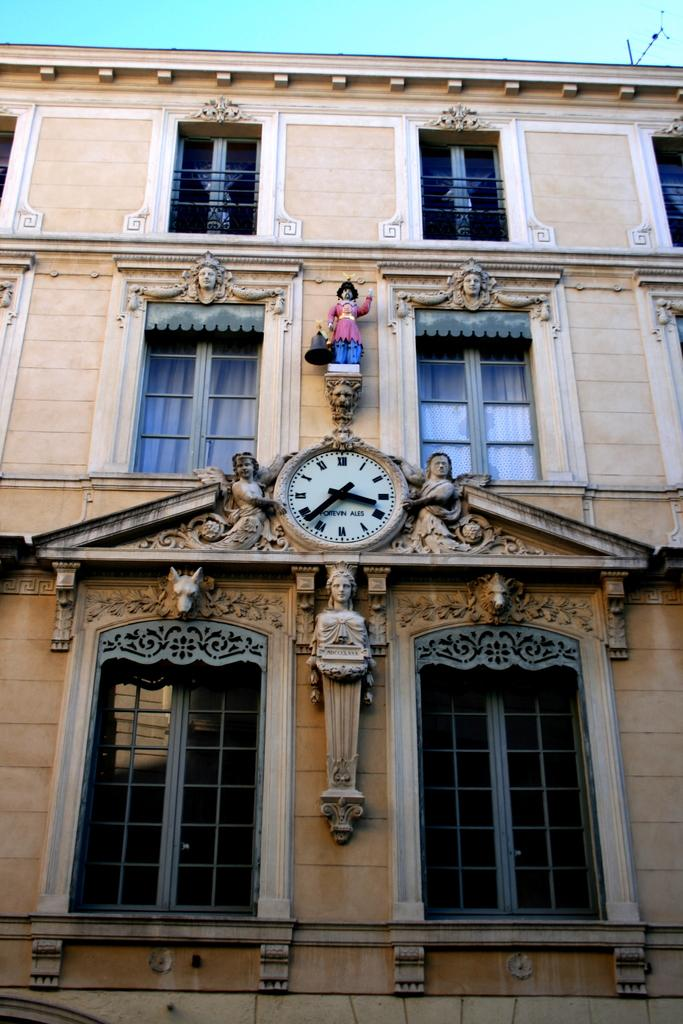Provide a one-sentence caption for the provided image. an ornate building with a clock saying it is twenty to four. 